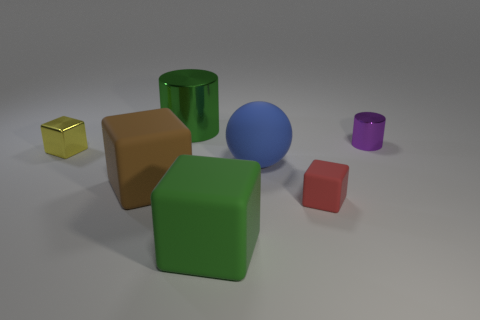Subtract 1 cubes. How many cubes are left? 3 Add 2 large metal spheres. How many objects exist? 9 Subtract all cylinders. How many objects are left? 5 Subtract all small gray rubber cubes. Subtract all purple metal things. How many objects are left? 6 Add 3 big green cylinders. How many big green cylinders are left? 4 Add 6 big cylinders. How many big cylinders exist? 7 Subtract 1 brown blocks. How many objects are left? 6 